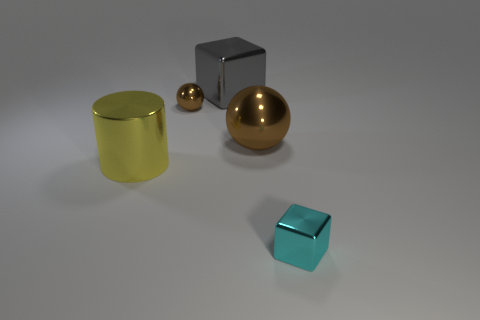Is there anything else that is the same shape as the big yellow metal object?
Offer a very short reply. No. There is a cube in front of the large gray metallic cube; is its color the same as the tiny metal object that is behind the big brown shiny object?
Offer a terse response. No. What is the color of the metal thing that is both on the left side of the big block and behind the cylinder?
Give a very brief answer. Brown. What number of other things are the same shape as the large yellow thing?
Offer a terse response. 0. There is another metal thing that is the same size as the cyan metallic object; what color is it?
Your answer should be compact. Brown. What color is the shiny block to the left of the tiny cyan block?
Give a very brief answer. Gray. There is a shiny block that is behind the small cyan metallic object; are there any big brown things to the left of it?
Keep it short and to the point. No. There is a big brown thing; does it have the same shape as the brown thing that is on the left side of the large brown ball?
Provide a short and direct response. Yes. There is a metallic thing that is both left of the large brown object and in front of the small brown ball; what is its size?
Your answer should be compact. Large. Are there any large brown spheres that have the same material as the tiny brown ball?
Your answer should be very brief. Yes. 